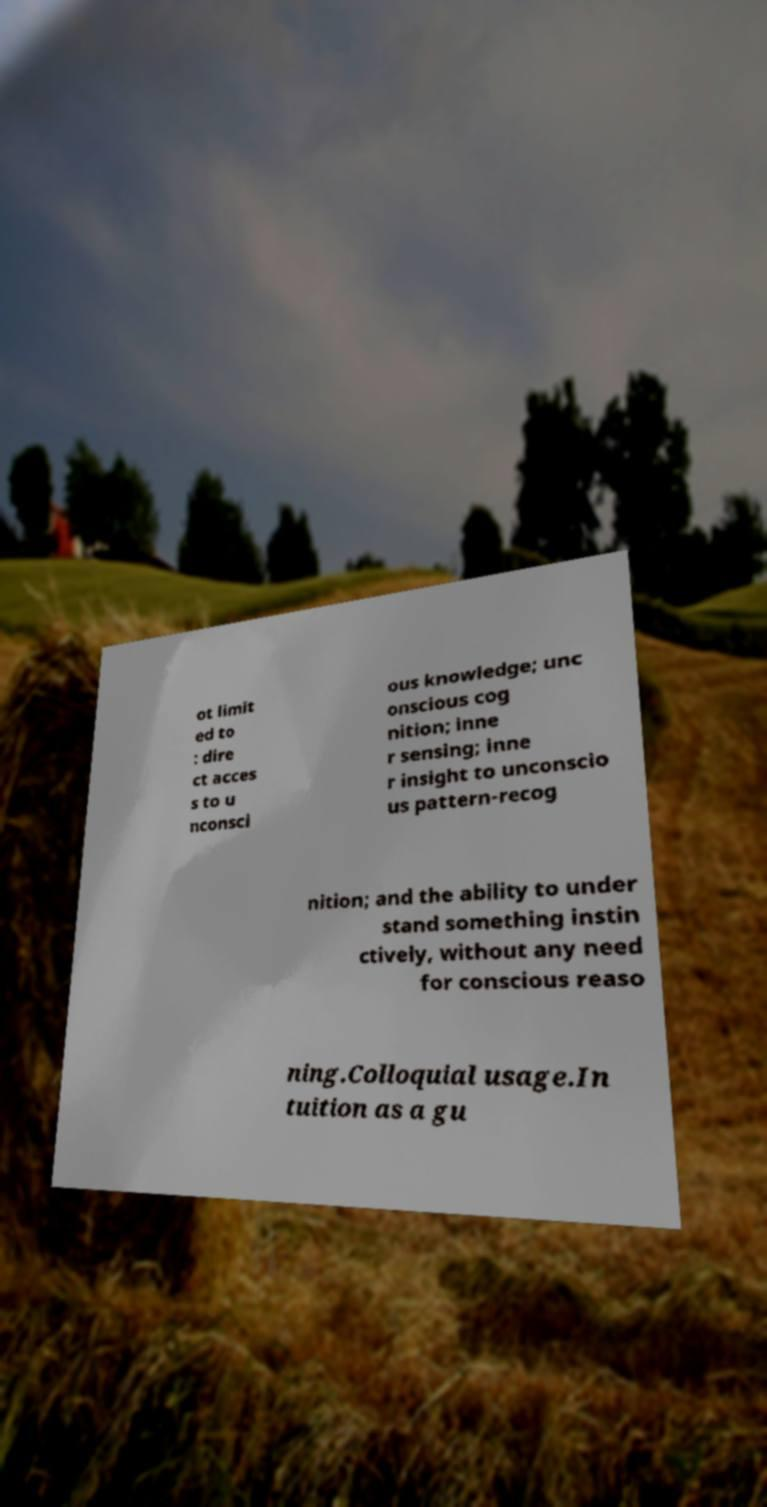For documentation purposes, I need the text within this image transcribed. Could you provide that? ot limit ed to : dire ct acces s to u nconsci ous knowledge; unc onscious cog nition; inne r sensing; inne r insight to unconscio us pattern-recog nition; and the ability to under stand something instin ctively, without any need for conscious reaso ning.Colloquial usage.In tuition as a gu 